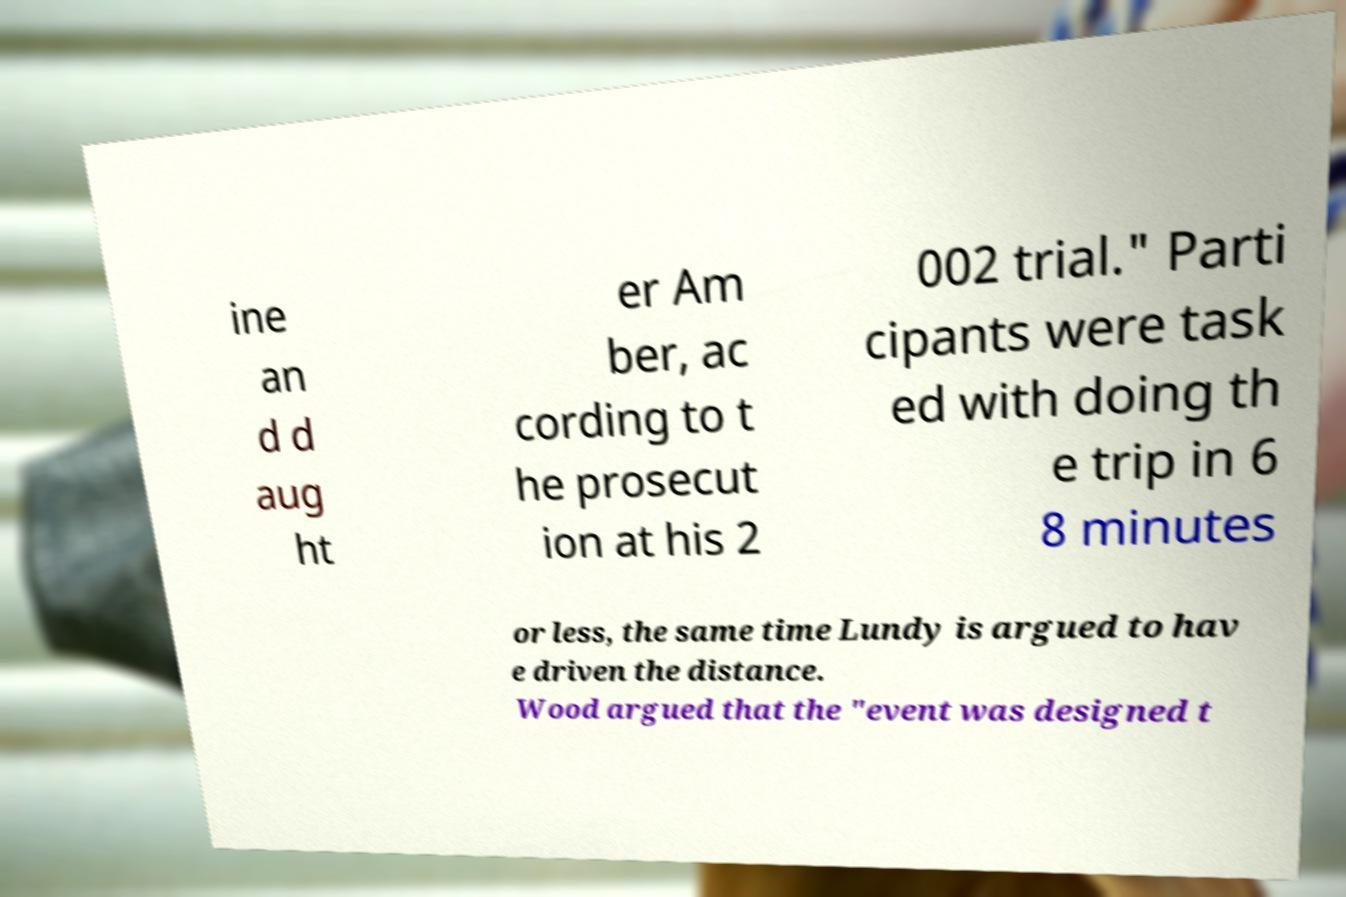Can you read and provide the text displayed in the image?This photo seems to have some interesting text. Can you extract and type it out for me? ine an d d aug ht er Am ber, ac cording to t he prosecut ion at his 2 002 trial." Parti cipants were task ed with doing th e trip in 6 8 minutes or less, the same time Lundy is argued to hav e driven the distance. Wood argued that the "event was designed t 